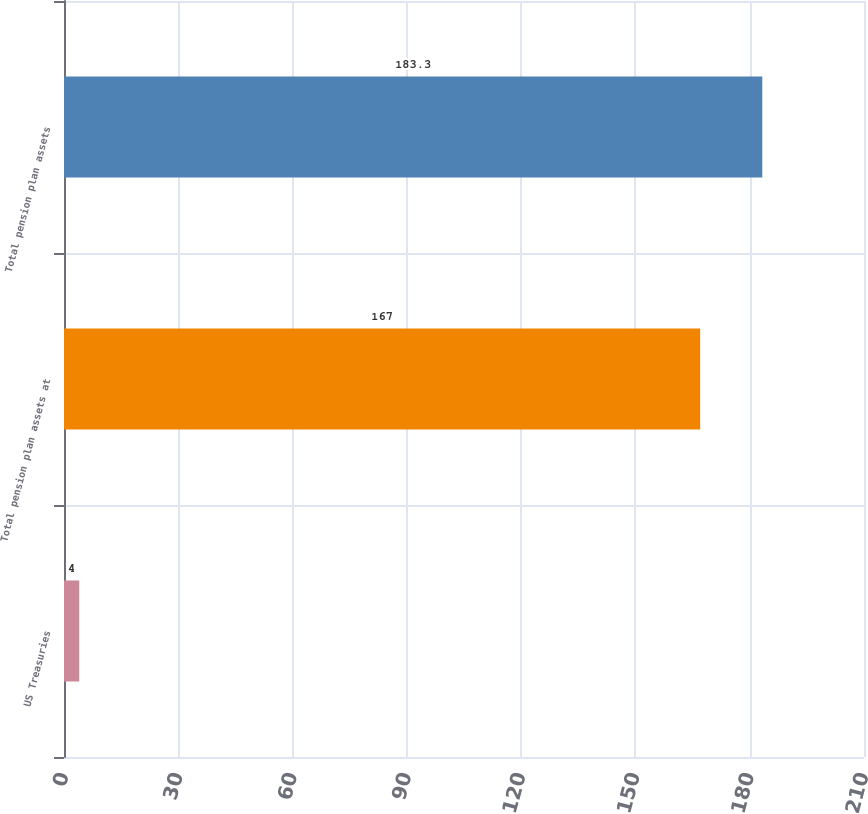Convert chart. <chart><loc_0><loc_0><loc_500><loc_500><bar_chart><fcel>US Treasuries<fcel>Total pension plan assets at<fcel>Total pension plan assets<nl><fcel>4<fcel>167<fcel>183.3<nl></chart> 